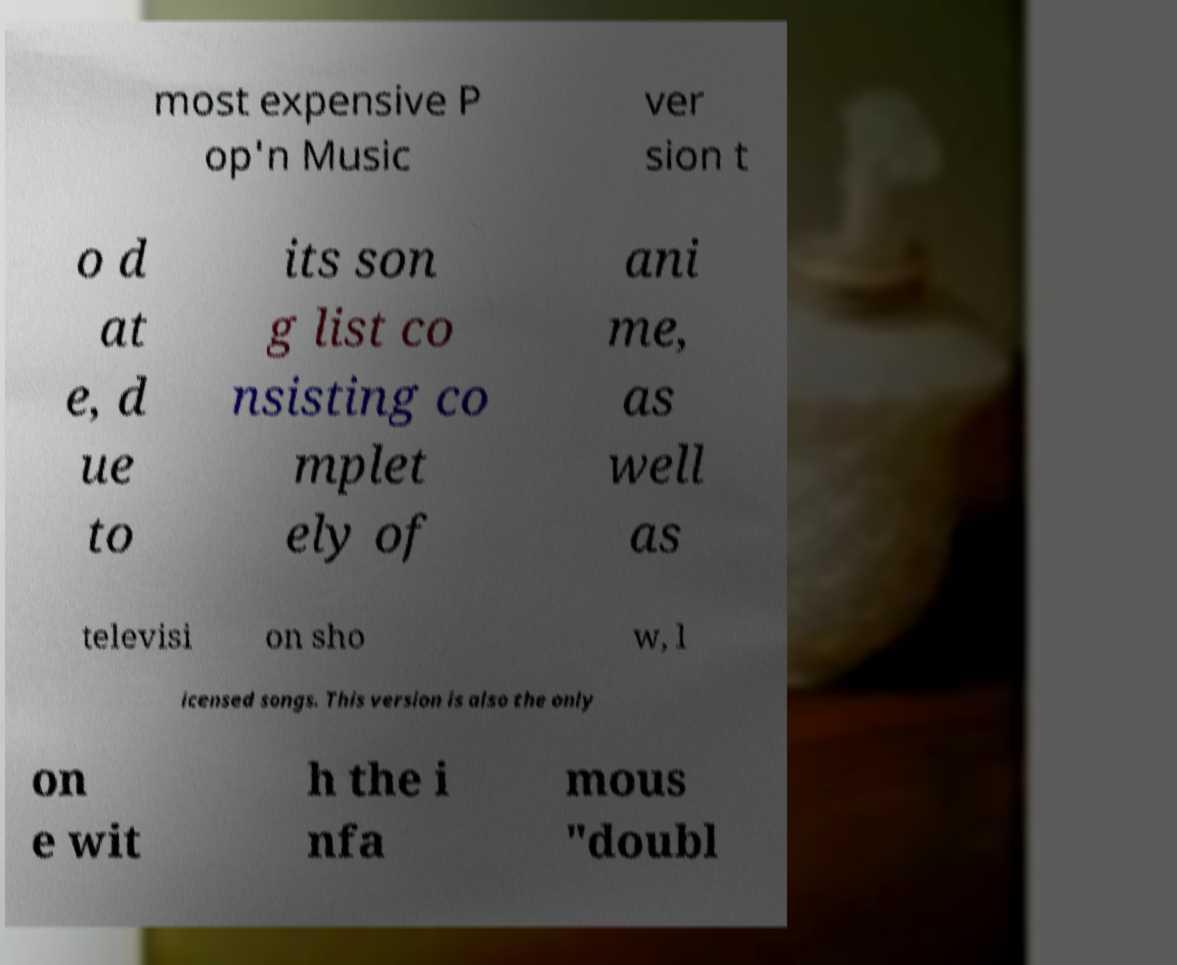Please identify and transcribe the text found in this image. most expensive P op'n Music ver sion t o d at e, d ue to its son g list co nsisting co mplet ely of ani me, as well as televisi on sho w, l icensed songs. This version is also the only on e wit h the i nfa mous "doubl 